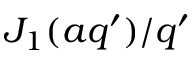Convert formula to latex. <formula><loc_0><loc_0><loc_500><loc_500>J _ { 1 } ( a q ^ { \prime } ) / q ^ { \prime }</formula> 